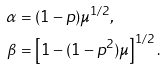Convert formula to latex. <formula><loc_0><loc_0><loc_500><loc_500>\alpha & = ( 1 - p ) \mu ^ { 1 / 2 } , \\ \beta & = \left [ 1 - ( 1 - p ^ { 2 } ) \mu \right ] ^ { 1 / 2 } .</formula> 